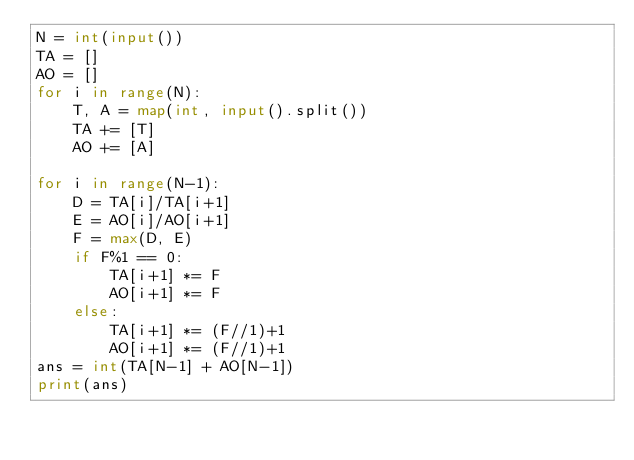<code> <loc_0><loc_0><loc_500><loc_500><_Python_>N = int(input())
TA = []
AO = []
for i in range(N):
    T, A = map(int, input().split())
    TA += [T]
    AO += [A]

for i in range(N-1):
    D = TA[i]/TA[i+1]
    E = AO[i]/AO[i+1]
    F = max(D, E)
    if F%1 == 0:
        TA[i+1] *= F
        AO[i+1] *= F
    else:
        TA[i+1] *= (F//1)+1
        AO[i+1] *= (F//1)+1
ans = int(TA[N-1] + AO[N-1])
print(ans)</code> 